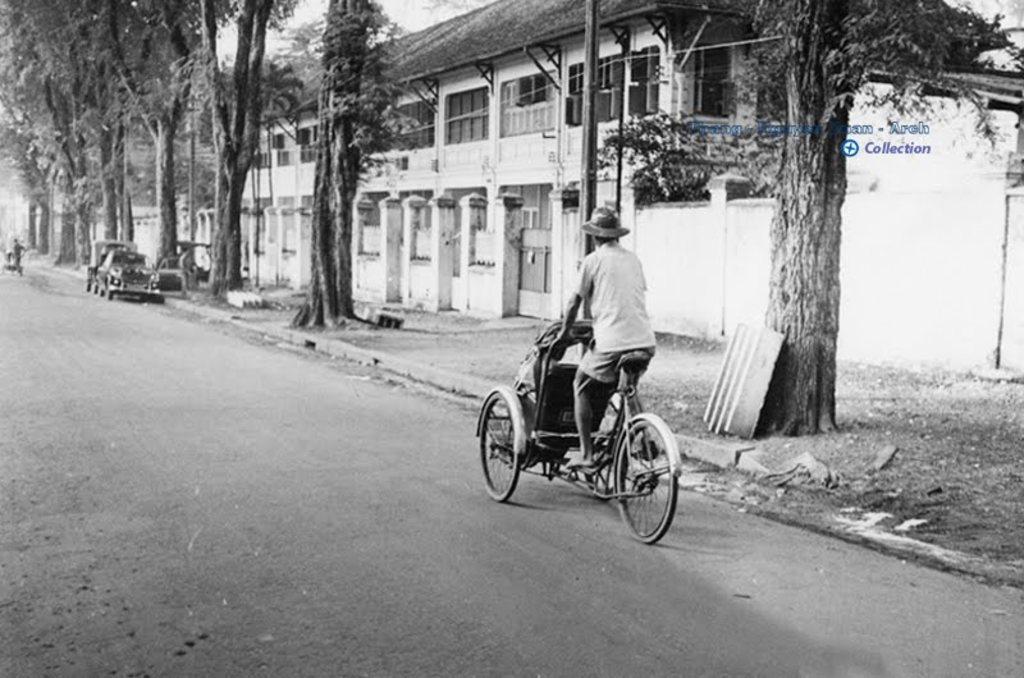Describe this image in one or two sentences. In this picture we can see a person is riding a tricycle on the road, in the background we can see couple of buildings, cars and trees. 